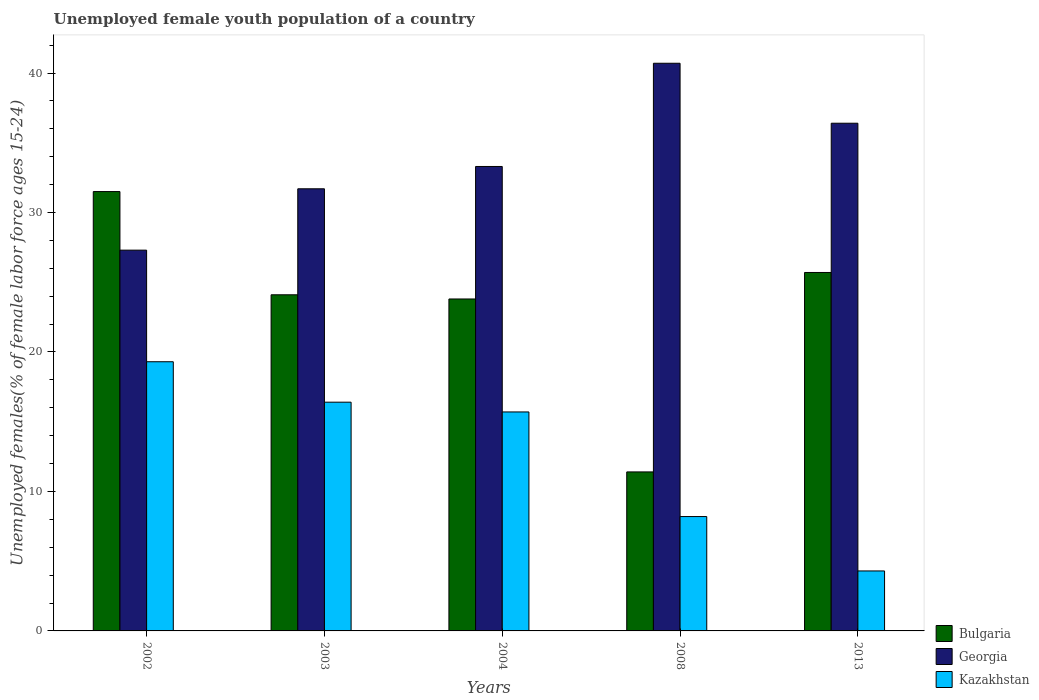How many different coloured bars are there?
Keep it short and to the point. 3. How many groups of bars are there?
Make the answer very short. 5. Are the number of bars per tick equal to the number of legend labels?
Your response must be concise. Yes. Are the number of bars on each tick of the X-axis equal?
Provide a short and direct response. Yes. What is the label of the 5th group of bars from the left?
Your response must be concise. 2013. What is the percentage of unemployed female youth population in Bulgaria in 2008?
Provide a succinct answer. 11.4. Across all years, what is the maximum percentage of unemployed female youth population in Bulgaria?
Your answer should be very brief. 31.5. Across all years, what is the minimum percentage of unemployed female youth population in Georgia?
Offer a very short reply. 27.3. In which year was the percentage of unemployed female youth population in Kazakhstan maximum?
Provide a short and direct response. 2002. What is the total percentage of unemployed female youth population in Bulgaria in the graph?
Provide a succinct answer. 116.5. What is the difference between the percentage of unemployed female youth population in Bulgaria in 2002 and that in 2003?
Ensure brevity in your answer.  7.4. What is the difference between the percentage of unemployed female youth population in Georgia in 2008 and the percentage of unemployed female youth population in Bulgaria in 2002?
Provide a succinct answer. 9.2. What is the average percentage of unemployed female youth population in Bulgaria per year?
Keep it short and to the point. 23.3. In the year 2003, what is the difference between the percentage of unemployed female youth population in Bulgaria and percentage of unemployed female youth population in Georgia?
Offer a very short reply. -7.6. In how many years, is the percentage of unemployed female youth population in Georgia greater than 26 %?
Give a very brief answer. 5. What is the ratio of the percentage of unemployed female youth population in Bulgaria in 2003 to that in 2013?
Your response must be concise. 0.94. Is the difference between the percentage of unemployed female youth population in Bulgaria in 2004 and 2008 greater than the difference between the percentage of unemployed female youth population in Georgia in 2004 and 2008?
Give a very brief answer. Yes. What is the difference between the highest and the second highest percentage of unemployed female youth population in Kazakhstan?
Give a very brief answer. 2.9. What is the difference between the highest and the lowest percentage of unemployed female youth population in Bulgaria?
Give a very brief answer. 20.1. What does the 3rd bar from the left in 2002 represents?
Ensure brevity in your answer.  Kazakhstan. What does the 1st bar from the right in 2002 represents?
Provide a succinct answer. Kazakhstan. Is it the case that in every year, the sum of the percentage of unemployed female youth population in Kazakhstan and percentage of unemployed female youth population in Georgia is greater than the percentage of unemployed female youth population in Bulgaria?
Ensure brevity in your answer.  Yes. How many years are there in the graph?
Keep it short and to the point. 5. Are the values on the major ticks of Y-axis written in scientific E-notation?
Provide a succinct answer. No. Does the graph contain grids?
Make the answer very short. No. How many legend labels are there?
Make the answer very short. 3. What is the title of the graph?
Make the answer very short. Unemployed female youth population of a country. What is the label or title of the Y-axis?
Give a very brief answer. Unemployed females(% of female labor force ages 15-24). What is the Unemployed females(% of female labor force ages 15-24) in Bulgaria in 2002?
Offer a terse response. 31.5. What is the Unemployed females(% of female labor force ages 15-24) in Georgia in 2002?
Offer a terse response. 27.3. What is the Unemployed females(% of female labor force ages 15-24) in Kazakhstan in 2002?
Your answer should be compact. 19.3. What is the Unemployed females(% of female labor force ages 15-24) in Bulgaria in 2003?
Your response must be concise. 24.1. What is the Unemployed females(% of female labor force ages 15-24) in Georgia in 2003?
Provide a succinct answer. 31.7. What is the Unemployed females(% of female labor force ages 15-24) in Kazakhstan in 2003?
Provide a succinct answer. 16.4. What is the Unemployed females(% of female labor force ages 15-24) in Bulgaria in 2004?
Your answer should be compact. 23.8. What is the Unemployed females(% of female labor force ages 15-24) of Georgia in 2004?
Give a very brief answer. 33.3. What is the Unemployed females(% of female labor force ages 15-24) in Kazakhstan in 2004?
Offer a terse response. 15.7. What is the Unemployed females(% of female labor force ages 15-24) in Bulgaria in 2008?
Provide a short and direct response. 11.4. What is the Unemployed females(% of female labor force ages 15-24) in Georgia in 2008?
Your response must be concise. 40.7. What is the Unemployed females(% of female labor force ages 15-24) in Kazakhstan in 2008?
Give a very brief answer. 8.2. What is the Unemployed females(% of female labor force ages 15-24) in Bulgaria in 2013?
Your response must be concise. 25.7. What is the Unemployed females(% of female labor force ages 15-24) in Georgia in 2013?
Provide a succinct answer. 36.4. What is the Unemployed females(% of female labor force ages 15-24) in Kazakhstan in 2013?
Keep it short and to the point. 4.3. Across all years, what is the maximum Unemployed females(% of female labor force ages 15-24) in Bulgaria?
Keep it short and to the point. 31.5. Across all years, what is the maximum Unemployed females(% of female labor force ages 15-24) of Georgia?
Ensure brevity in your answer.  40.7. Across all years, what is the maximum Unemployed females(% of female labor force ages 15-24) of Kazakhstan?
Your answer should be compact. 19.3. Across all years, what is the minimum Unemployed females(% of female labor force ages 15-24) of Bulgaria?
Your answer should be very brief. 11.4. Across all years, what is the minimum Unemployed females(% of female labor force ages 15-24) of Georgia?
Offer a very short reply. 27.3. Across all years, what is the minimum Unemployed females(% of female labor force ages 15-24) of Kazakhstan?
Give a very brief answer. 4.3. What is the total Unemployed females(% of female labor force ages 15-24) of Bulgaria in the graph?
Your response must be concise. 116.5. What is the total Unemployed females(% of female labor force ages 15-24) in Georgia in the graph?
Offer a terse response. 169.4. What is the total Unemployed females(% of female labor force ages 15-24) in Kazakhstan in the graph?
Offer a very short reply. 63.9. What is the difference between the Unemployed females(% of female labor force ages 15-24) of Bulgaria in 2002 and that in 2003?
Provide a short and direct response. 7.4. What is the difference between the Unemployed females(% of female labor force ages 15-24) of Kazakhstan in 2002 and that in 2003?
Provide a succinct answer. 2.9. What is the difference between the Unemployed females(% of female labor force ages 15-24) of Bulgaria in 2002 and that in 2004?
Your response must be concise. 7.7. What is the difference between the Unemployed females(% of female labor force ages 15-24) in Georgia in 2002 and that in 2004?
Offer a terse response. -6. What is the difference between the Unemployed females(% of female labor force ages 15-24) of Bulgaria in 2002 and that in 2008?
Provide a short and direct response. 20.1. What is the difference between the Unemployed females(% of female labor force ages 15-24) in Georgia in 2002 and that in 2008?
Your response must be concise. -13.4. What is the difference between the Unemployed females(% of female labor force ages 15-24) in Kazakhstan in 2002 and that in 2008?
Provide a short and direct response. 11.1. What is the difference between the Unemployed females(% of female labor force ages 15-24) in Georgia in 2003 and that in 2008?
Make the answer very short. -9. What is the difference between the Unemployed females(% of female labor force ages 15-24) of Kazakhstan in 2003 and that in 2008?
Provide a short and direct response. 8.2. What is the difference between the Unemployed females(% of female labor force ages 15-24) in Bulgaria in 2003 and that in 2013?
Offer a very short reply. -1.6. What is the difference between the Unemployed females(% of female labor force ages 15-24) of Georgia in 2004 and that in 2008?
Keep it short and to the point. -7.4. What is the difference between the Unemployed females(% of female labor force ages 15-24) in Georgia in 2004 and that in 2013?
Offer a terse response. -3.1. What is the difference between the Unemployed females(% of female labor force ages 15-24) of Kazakhstan in 2004 and that in 2013?
Provide a short and direct response. 11.4. What is the difference between the Unemployed females(% of female labor force ages 15-24) in Bulgaria in 2008 and that in 2013?
Your answer should be very brief. -14.3. What is the difference between the Unemployed females(% of female labor force ages 15-24) of Georgia in 2008 and that in 2013?
Give a very brief answer. 4.3. What is the difference between the Unemployed females(% of female labor force ages 15-24) of Kazakhstan in 2008 and that in 2013?
Offer a terse response. 3.9. What is the difference between the Unemployed females(% of female labor force ages 15-24) of Bulgaria in 2002 and the Unemployed females(% of female labor force ages 15-24) of Georgia in 2003?
Your answer should be very brief. -0.2. What is the difference between the Unemployed females(% of female labor force ages 15-24) in Bulgaria in 2002 and the Unemployed females(% of female labor force ages 15-24) in Kazakhstan in 2003?
Give a very brief answer. 15.1. What is the difference between the Unemployed females(% of female labor force ages 15-24) of Georgia in 2002 and the Unemployed females(% of female labor force ages 15-24) of Kazakhstan in 2003?
Your answer should be compact. 10.9. What is the difference between the Unemployed females(% of female labor force ages 15-24) of Bulgaria in 2002 and the Unemployed females(% of female labor force ages 15-24) of Georgia in 2004?
Offer a very short reply. -1.8. What is the difference between the Unemployed females(% of female labor force ages 15-24) of Bulgaria in 2002 and the Unemployed females(% of female labor force ages 15-24) of Kazakhstan in 2004?
Your response must be concise. 15.8. What is the difference between the Unemployed females(% of female labor force ages 15-24) of Bulgaria in 2002 and the Unemployed females(% of female labor force ages 15-24) of Georgia in 2008?
Offer a terse response. -9.2. What is the difference between the Unemployed females(% of female labor force ages 15-24) of Bulgaria in 2002 and the Unemployed females(% of female labor force ages 15-24) of Kazakhstan in 2008?
Your answer should be compact. 23.3. What is the difference between the Unemployed females(% of female labor force ages 15-24) of Bulgaria in 2002 and the Unemployed females(% of female labor force ages 15-24) of Georgia in 2013?
Ensure brevity in your answer.  -4.9. What is the difference between the Unemployed females(% of female labor force ages 15-24) in Bulgaria in 2002 and the Unemployed females(% of female labor force ages 15-24) in Kazakhstan in 2013?
Provide a short and direct response. 27.2. What is the difference between the Unemployed females(% of female labor force ages 15-24) of Georgia in 2002 and the Unemployed females(% of female labor force ages 15-24) of Kazakhstan in 2013?
Keep it short and to the point. 23. What is the difference between the Unemployed females(% of female labor force ages 15-24) in Bulgaria in 2003 and the Unemployed females(% of female labor force ages 15-24) in Georgia in 2008?
Provide a succinct answer. -16.6. What is the difference between the Unemployed females(% of female labor force ages 15-24) in Georgia in 2003 and the Unemployed females(% of female labor force ages 15-24) in Kazakhstan in 2008?
Make the answer very short. 23.5. What is the difference between the Unemployed females(% of female labor force ages 15-24) of Bulgaria in 2003 and the Unemployed females(% of female labor force ages 15-24) of Kazakhstan in 2013?
Keep it short and to the point. 19.8. What is the difference between the Unemployed females(% of female labor force ages 15-24) of Georgia in 2003 and the Unemployed females(% of female labor force ages 15-24) of Kazakhstan in 2013?
Offer a terse response. 27.4. What is the difference between the Unemployed females(% of female labor force ages 15-24) of Bulgaria in 2004 and the Unemployed females(% of female labor force ages 15-24) of Georgia in 2008?
Provide a short and direct response. -16.9. What is the difference between the Unemployed females(% of female labor force ages 15-24) of Georgia in 2004 and the Unemployed females(% of female labor force ages 15-24) of Kazakhstan in 2008?
Offer a terse response. 25.1. What is the difference between the Unemployed females(% of female labor force ages 15-24) in Bulgaria in 2004 and the Unemployed females(% of female labor force ages 15-24) in Kazakhstan in 2013?
Offer a very short reply. 19.5. What is the difference between the Unemployed females(% of female labor force ages 15-24) in Georgia in 2004 and the Unemployed females(% of female labor force ages 15-24) in Kazakhstan in 2013?
Offer a terse response. 29. What is the difference between the Unemployed females(% of female labor force ages 15-24) in Bulgaria in 2008 and the Unemployed females(% of female labor force ages 15-24) in Georgia in 2013?
Make the answer very short. -25. What is the difference between the Unemployed females(% of female labor force ages 15-24) in Georgia in 2008 and the Unemployed females(% of female labor force ages 15-24) in Kazakhstan in 2013?
Give a very brief answer. 36.4. What is the average Unemployed females(% of female labor force ages 15-24) in Bulgaria per year?
Offer a very short reply. 23.3. What is the average Unemployed females(% of female labor force ages 15-24) of Georgia per year?
Offer a very short reply. 33.88. What is the average Unemployed females(% of female labor force ages 15-24) in Kazakhstan per year?
Your response must be concise. 12.78. In the year 2002, what is the difference between the Unemployed females(% of female labor force ages 15-24) in Bulgaria and Unemployed females(% of female labor force ages 15-24) in Kazakhstan?
Your answer should be very brief. 12.2. In the year 2002, what is the difference between the Unemployed females(% of female labor force ages 15-24) of Georgia and Unemployed females(% of female labor force ages 15-24) of Kazakhstan?
Your response must be concise. 8. In the year 2003, what is the difference between the Unemployed females(% of female labor force ages 15-24) in Bulgaria and Unemployed females(% of female labor force ages 15-24) in Kazakhstan?
Offer a terse response. 7.7. In the year 2003, what is the difference between the Unemployed females(% of female labor force ages 15-24) in Georgia and Unemployed females(% of female labor force ages 15-24) in Kazakhstan?
Provide a succinct answer. 15.3. In the year 2004, what is the difference between the Unemployed females(% of female labor force ages 15-24) in Bulgaria and Unemployed females(% of female labor force ages 15-24) in Georgia?
Make the answer very short. -9.5. In the year 2004, what is the difference between the Unemployed females(% of female labor force ages 15-24) in Georgia and Unemployed females(% of female labor force ages 15-24) in Kazakhstan?
Your answer should be compact. 17.6. In the year 2008, what is the difference between the Unemployed females(% of female labor force ages 15-24) in Bulgaria and Unemployed females(% of female labor force ages 15-24) in Georgia?
Your response must be concise. -29.3. In the year 2008, what is the difference between the Unemployed females(% of female labor force ages 15-24) of Georgia and Unemployed females(% of female labor force ages 15-24) of Kazakhstan?
Offer a very short reply. 32.5. In the year 2013, what is the difference between the Unemployed females(% of female labor force ages 15-24) in Bulgaria and Unemployed females(% of female labor force ages 15-24) in Kazakhstan?
Make the answer very short. 21.4. In the year 2013, what is the difference between the Unemployed females(% of female labor force ages 15-24) in Georgia and Unemployed females(% of female labor force ages 15-24) in Kazakhstan?
Provide a short and direct response. 32.1. What is the ratio of the Unemployed females(% of female labor force ages 15-24) of Bulgaria in 2002 to that in 2003?
Keep it short and to the point. 1.31. What is the ratio of the Unemployed females(% of female labor force ages 15-24) of Georgia in 2002 to that in 2003?
Ensure brevity in your answer.  0.86. What is the ratio of the Unemployed females(% of female labor force ages 15-24) in Kazakhstan in 2002 to that in 2003?
Keep it short and to the point. 1.18. What is the ratio of the Unemployed females(% of female labor force ages 15-24) in Bulgaria in 2002 to that in 2004?
Ensure brevity in your answer.  1.32. What is the ratio of the Unemployed females(% of female labor force ages 15-24) of Georgia in 2002 to that in 2004?
Offer a very short reply. 0.82. What is the ratio of the Unemployed females(% of female labor force ages 15-24) in Kazakhstan in 2002 to that in 2004?
Offer a terse response. 1.23. What is the ratio of the Unemployed females(% of female labor force ages 15-24) of Bulgaria in 2002 to that in 2008?
Make the answer very short. 2.76. What is the ratio of the Unemployed females(% of female labor force ages 15-24) of Georgia in 2002 to that in 2008?
Provide a succinct answer. 0.67. What is the ratio of the Unemployed females(% of female labor force ages 15-24) in Kazakhstan in 2002 to that in 2008?
Ensure brevity in your answer.  2.35. What is the ratio of the Unemployed females(% of female labor force ages 15-24) in Bulgaria in 2002 to that in 2013?
Offer a terse response. 1.23. What is the ratio of the Unemployed females(% of female labor force ages 15-24) of Kazakhstan in 2002 to that in 2013?
Offer a very short reply. 4.49. What is the ratio of the Unemployed females(% of female labor force ages 15-24) of Bulgaria in 2003 to that in 2004?
Your response must be concise. 1.01. What is the ratio of the Unemployed females(% of female labor force ages 15-24) in Kazakhstan in 2003 to that in 2004?
Your response must be concise. 1.04. What is the ratio of the Unemployed females(% of female labor force ages 15-24) of Bulgaria in 2003 to that in 2008?
Provide a succinct answer. 2.11. What is the ratio of the Unemployed females(% of female labor force ages 15-24) of Georgia in 2003 to that in 2008?
Keep it short and to the point. 0.78. What is the ratio of the Unemployed females(% of female labor force ages 15-24) in Kazakhstan in 2003 to that in 2008?
Provide a succinct answer. 2. What is the ratio of the Unemployed females(% of female labor force ages 15-24) of Bulgaria in 2003 to that in 2013?
Provide a succinct answer. 0.94. What is the ratio of the Unemployed females(% of female labor force ages 15-24) of Georgia in 2003 to that in 2013?
Give a very brief answer. 0.87. What is the ratio of the Unemployed females(% of female labor force ages 15-24) in Kazakhstan in 2003 to that in 2013?
Keep it short and to the point. 3.81. What is the ratio of the Unemployed females(% of female labor force ages 15-24) of Bulgaria in 2004 to that in 2008?
Give a very brief answer. 2.09. What is the ratio of the Unemployed females(% of female labor force ages 15-24) in Georgia in 2004 to that in 2008?
Your response must be concise. 0.82. What is the ratio of the Unemployed females(% of female labor force ages 15-24) in Kazakhstan in 2004 to that in 2008?
Provide a succinct answer. 1.91. What is the ratio of the Unemployed females(% of female labor force ages 15-24) in Bulgaria in 2004 to that in 2013?
Give a very brief answer. 0.93. What is the ratio of the Unemployed females(% of female labor force ages 15-24) in Georgia in 2004 to that in 2013?
Give a very brief answer. 0.91. What is the ratio of the Unemployed females(% of female labor force ages 15-24) in Kazakhstan in 2004 to that in 2013?
Keep it short and to the point. 3.65. What is the ratio of the Unemployed females(% of female labor force ages 15-24) of Bulgaria in 2008 to that in 2013?
Keep it short and to the point. 0.44. What is the ratio of the Unemployed females(% of female labor force ages 15-24) in Georgia in 2008 to that in 2013?
Give a very brief answer. 1.12. What is the ratio of the Unemployed females(% of female labor force ages 15-24) in Kazakhstan in 2008 to that in 2013?
Offer a terse response. 1.91. What is the difference between the highest and the second highest Unemployed females(% of female labor force ages 15-24) of Bulgaria?
Provide a short and direct response. 5.8. What is the difference between the highest and the second highest Unemployed females(% of female labor force ages 15-24) in Kazakhstan?
Keep it short and to the point. 2.9. What is the difference between the highest and the lowest Unemployed females(% of female labor force ages 15-24) in Bulgaria?
Make the answer very short. 20.1. What is the difference between the highest and the lowest Unemployed females(% of female labor force ages 15-24) of Georgia?
Offer a very short reply. 13.4. What is the difference between the highest and the lowest Unemployed females(% of female labor force ages 15-24) of Kazakhstan?
Your answer should be very brief. 15. 